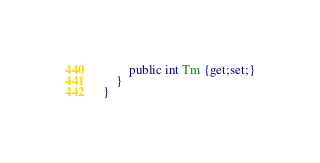Convert code to text. <code><loc_0><loc_0><loc_500><loc_500><_C#_>        public int Tm {get;set;}
    }
}</code> 